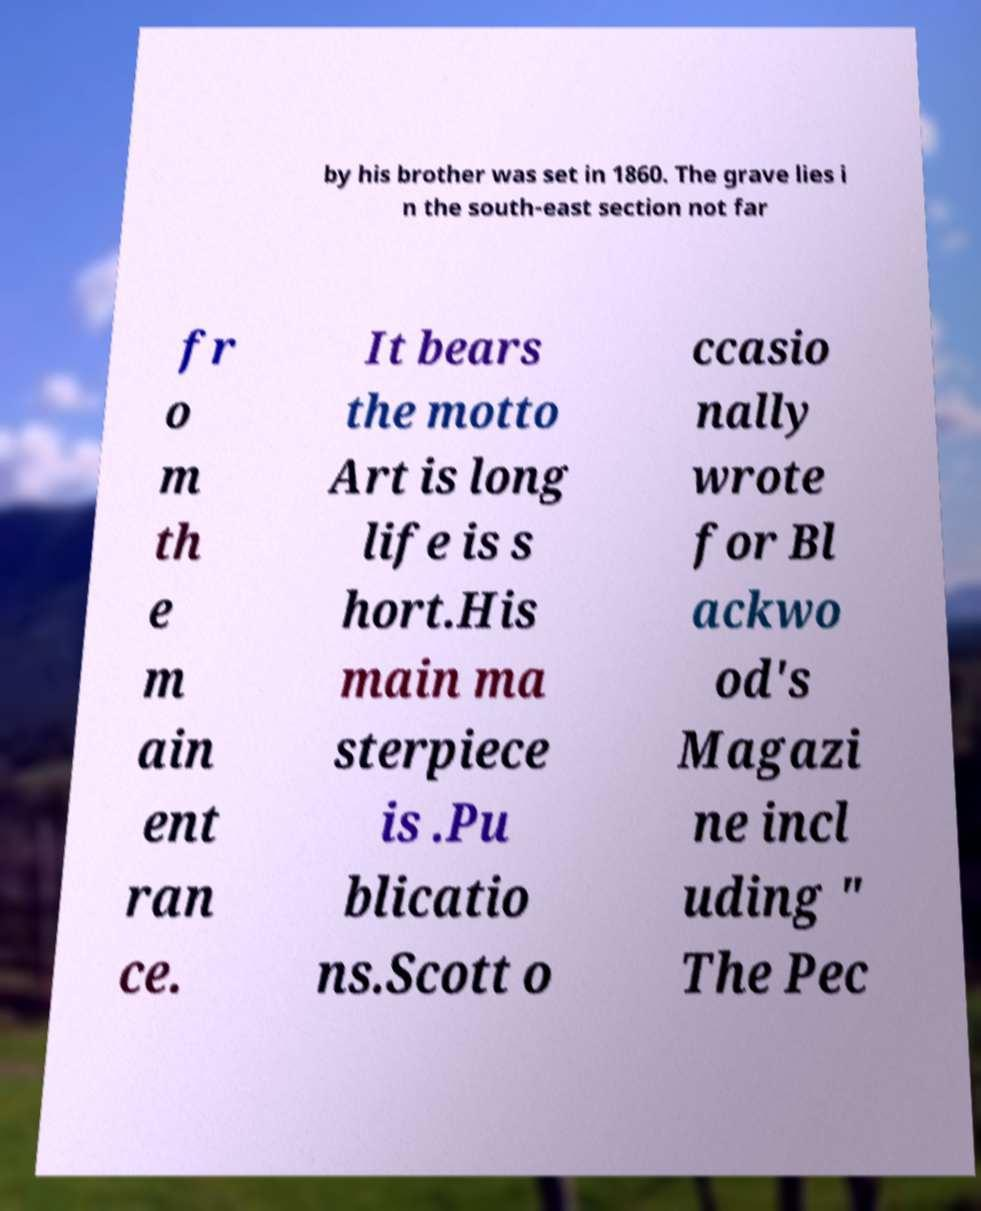I need the written content from this picture converted into text. Can you do that? by his brother was set in 1860. The grave lies i n the south-east section not far fr o m th e m ain ent ran ce. It bears the motto Art is long life is s hort.His main ma sterpiece is .Pu blicatio ns.Scott o ccasio nally wrote for Bl ackwo od's Magazi ne incl uding " The Pec 